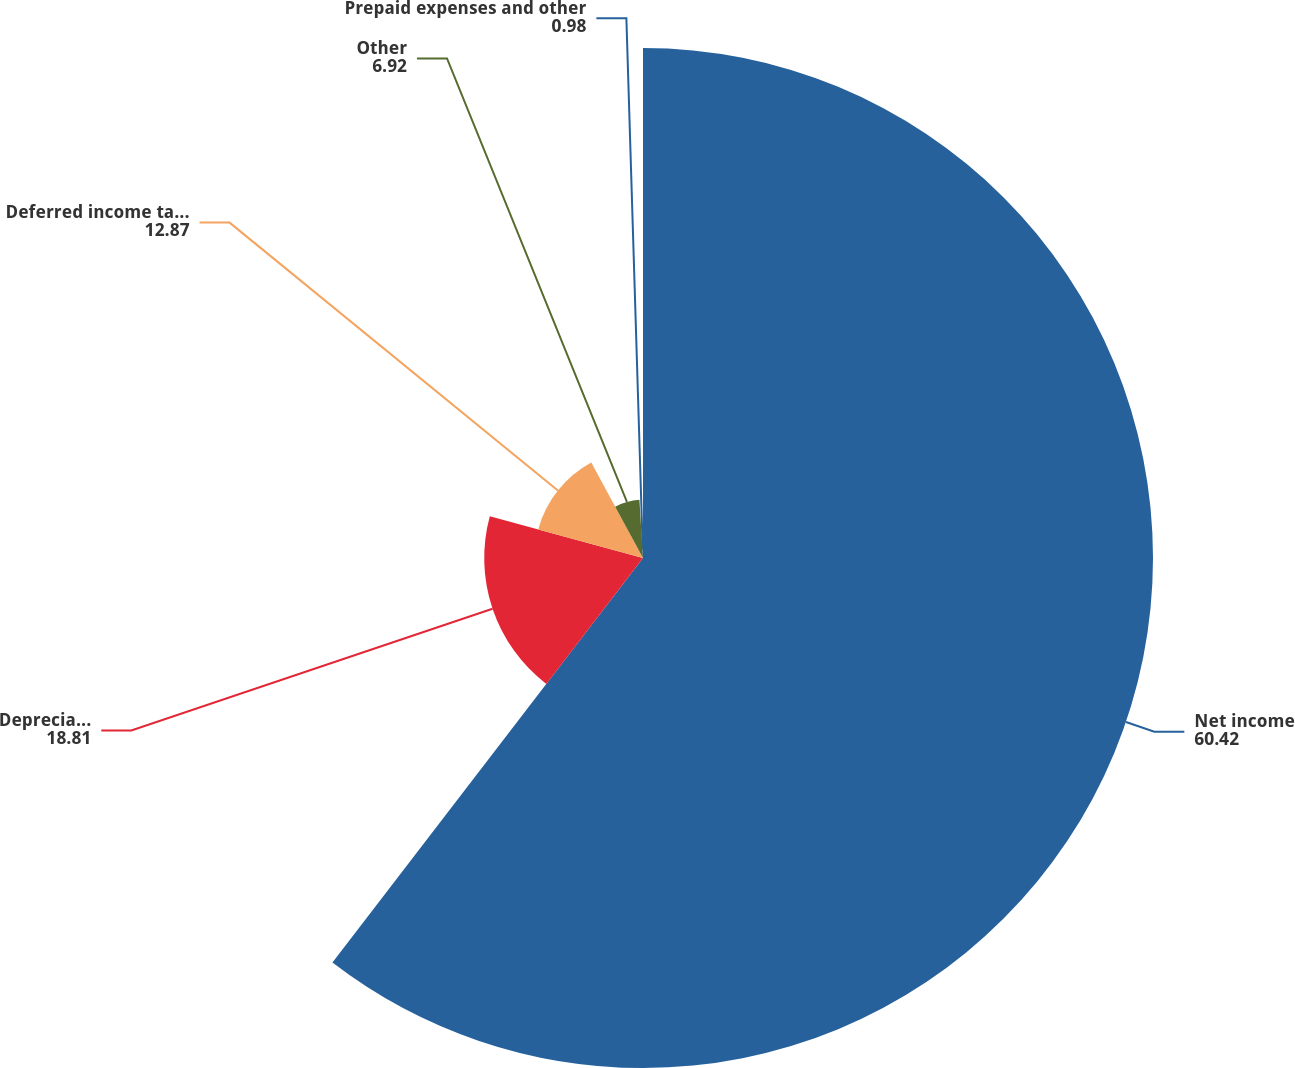<chart> <loc_0><loc_0><loc_500><loc_500><pie_chart><fcel>Net income<fcel>Depreciation and amortization<fcel>Deferred income taxes(a)<fcel>Other<fcel>Prepaid expenses and other<nl><fcel>60.42%<fcel>18.81%<fcel>12.87%<fcel>6.92%<fcel>0.98%<nl></chart> 